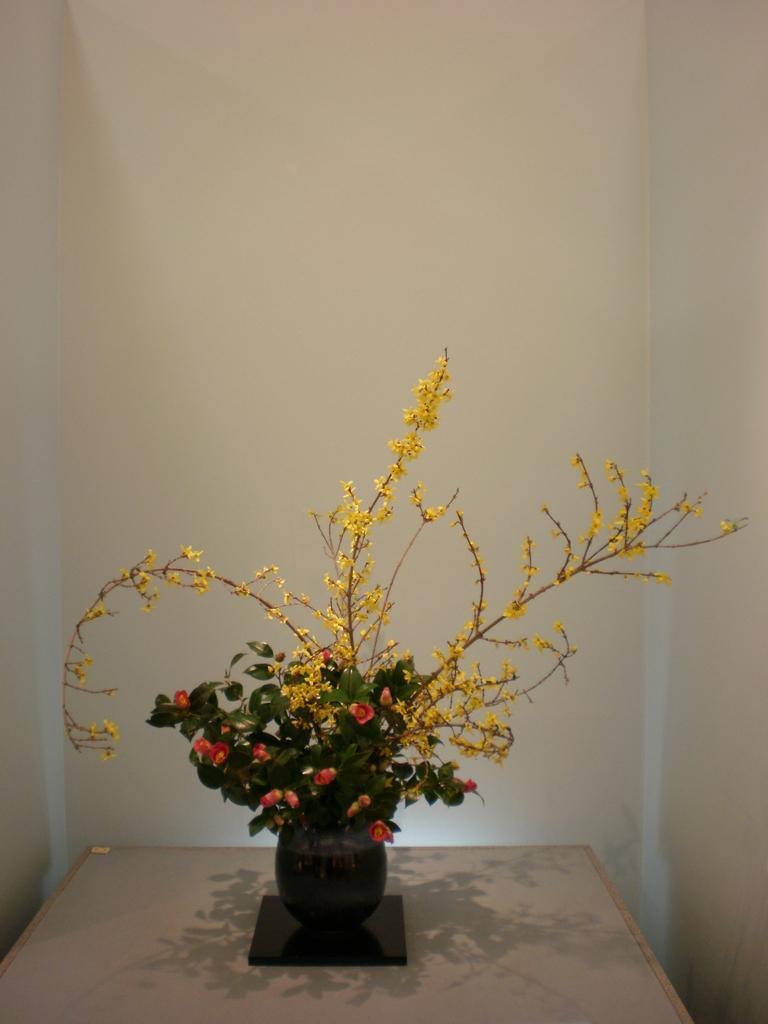How would you summarize this image in a sentence or two? In this image there is a flower pot with flowers in it, the pot is on top of a table. 